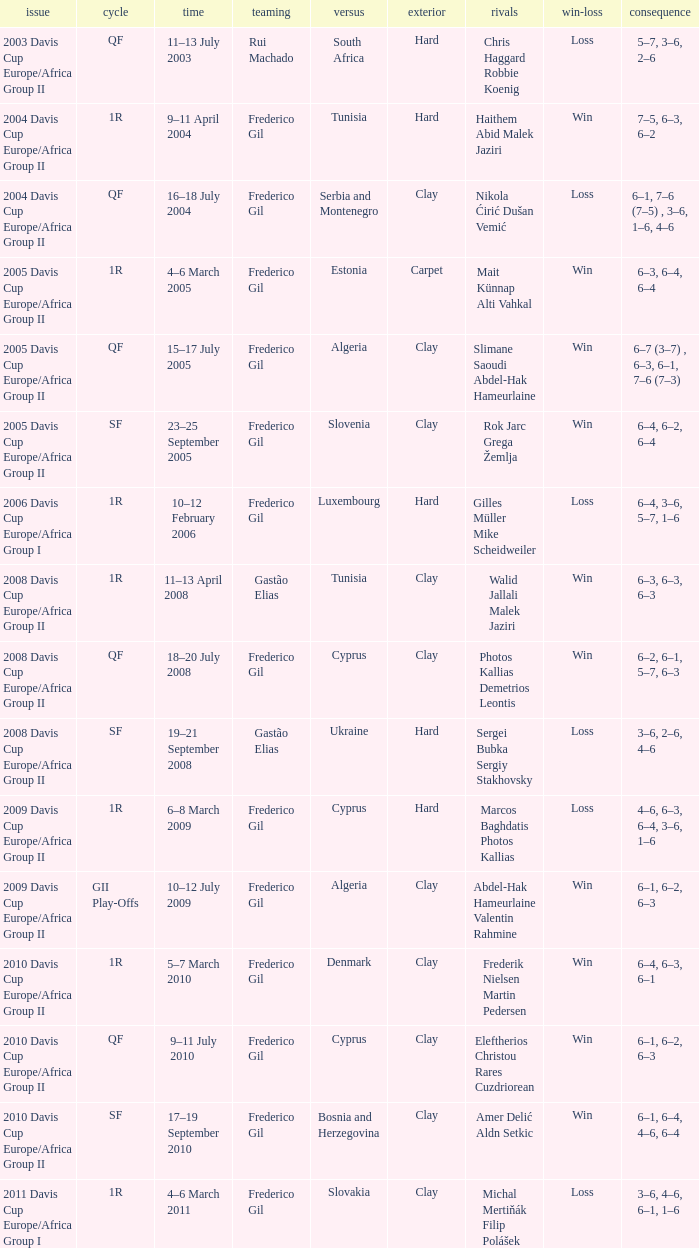How many rounds were there in the 2006 davis cup europe/africa group I? 1.0. 